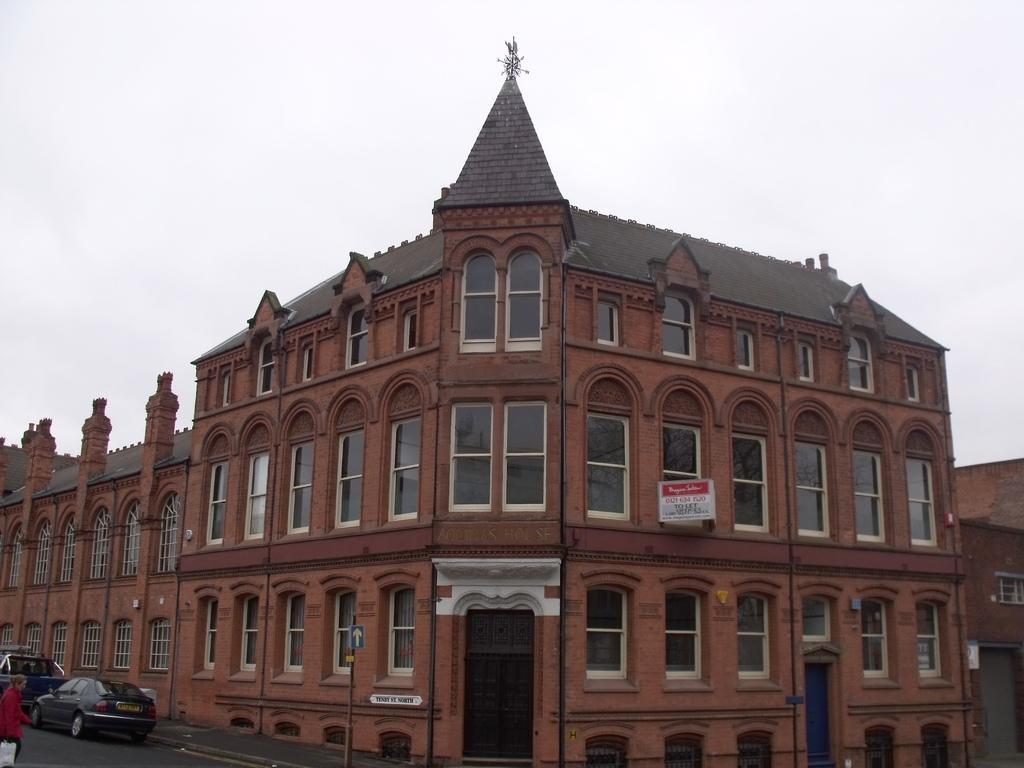Please provide a concise description of this image. In this image, we can see buildings, boards, a pole and there are vehicles on the road and we can see a person holding a bag. At the top, there is sky. 